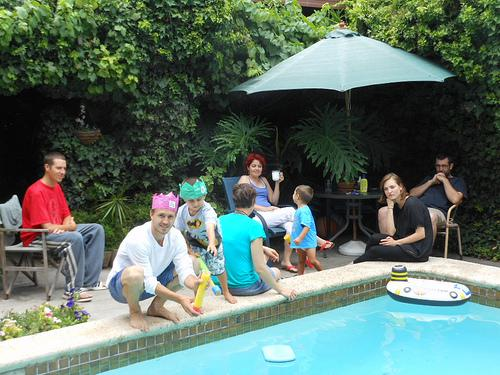Question: what color are the plants?
Choices:
A. Yellow.
B. Orange.
C. Green.
D. Blue.
Answer with the letter. Answer: C Question: what color are the bricks?
Choices:
A. Brown.
B. Red.
C. Orange.
D. Pink.
Answer with the letter. Answer: B Question: what are the pool walls made of?
Choices:
A. Bricks.
B. Cement.
C. Fiberglass.
D. Vinyl.
Answer with the letter. Answer: A Question: what is under the umbrella?
Choices:
A. A person.
B. A chair.
C. Sand.
D. A table.
Answer with the letter. Answer: D Question: where was the picture taken?
Choices:
A. Lakeshore.
B. Riverside.
C. Beach.
D. Poolside.
Answer with the letter. Answer: D 